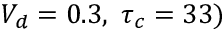<formula> <loc_0><loc_0><loc_500><loc_500>V _ { d } = 0 . 3 , \tau _ { c } = 3 3 )</formula> 